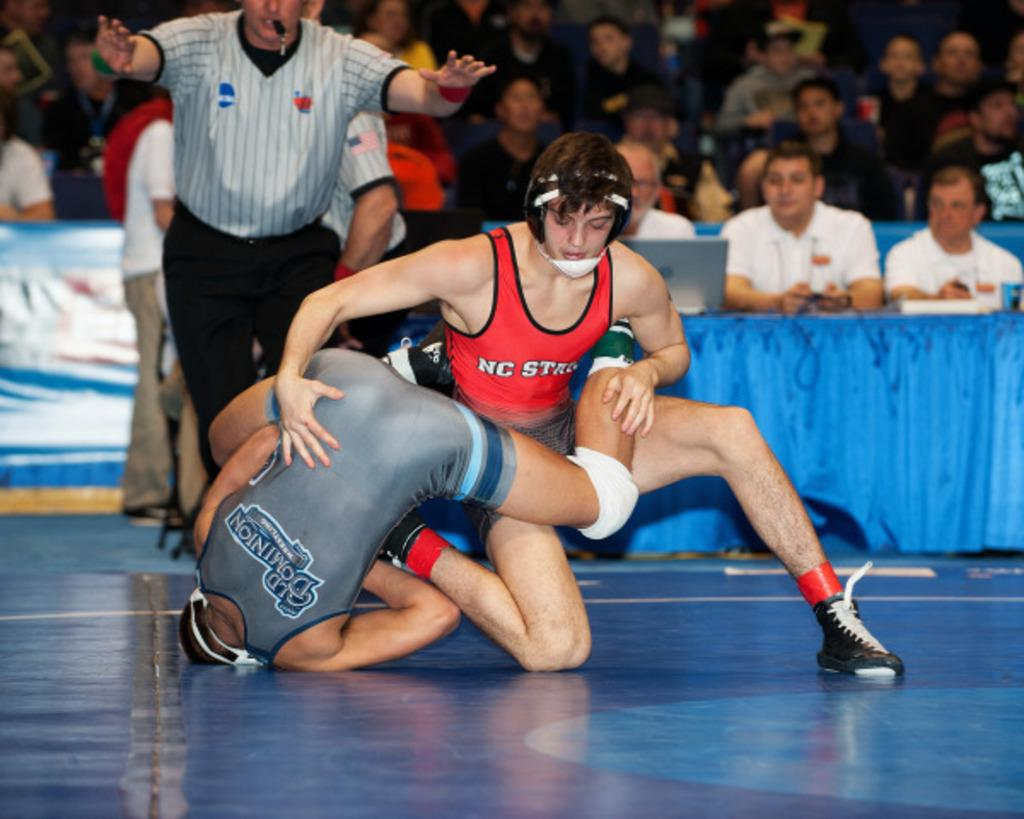<image>
Provide a brief description of the given image. Two wresters competing and one is from NC State 